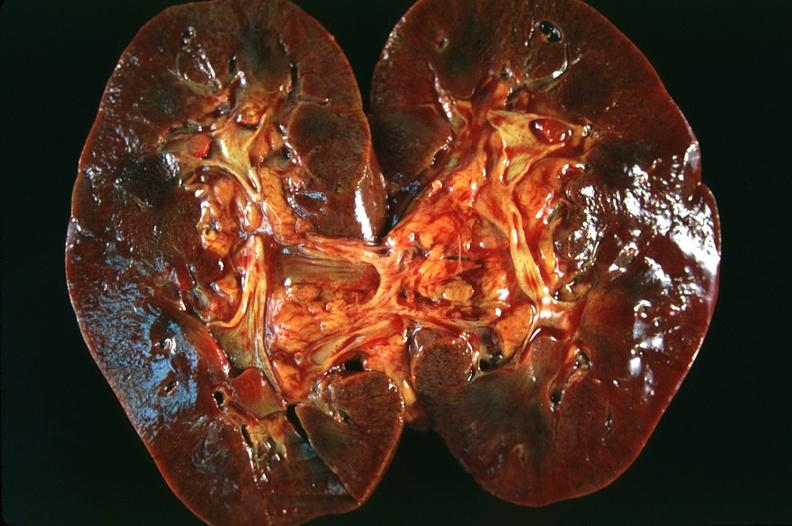does no tissue recognizable as ovary show kidney, congestion and blurring of the corticomedullary junction?
Answer the question using a single word or phrase. No 